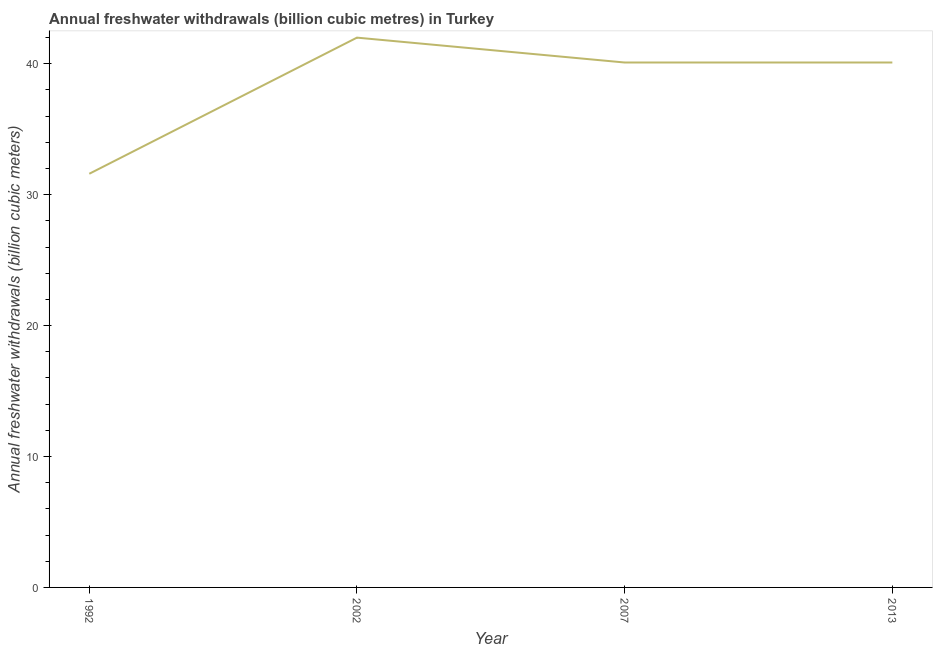What is the annual freshwater withdrawals in 2007?
Your answer should be compact. 40.1. Across all years, what is the minimum annual freshwater withdrawals?
Provide a succinct answer. 31.6. In which year was the annual freshwater withdrawals maximum?
Provide a short and direct response. 2002. What is the sum of the annual freshwater withdrawals?
Make the answer very short. 153.8. What is the difference between the annual freshwater withdrawals in 2002 and 2007?
Ensure brevity in your answer.  1.9. What is the average annual freshwater withdrawals per year?
Keep it short and to the point. 38.45. What is the median annual freshwater withdrawals?
Ensure brevity in your answer.  40.1. In how many years, is the annual freshwater withdrawals greater than 12 billion cubic meters?
Give a very brief answer. 4. Do a majority of the years between 2002 and 1992 (inclusive) have annual freshwater withdrawals greater than 30 billion cubic meters?
Your answer should be compact. No. What is the ratio of the annual freshwater withdrawals in 1992 to that in 2002?
Your answer should be very brief. 0.75. Is the annual freshwater withdrawals in 2007 less than that in 2013?
Give a very brief answer. No. Is the difference between the annual freshwater withdrawals in 2007 and 2013 greater than the difference between any two years?
Your answer should be very brief. No. What is the difference between the highest and the second highest annual freshwater withdrawals?
Your response must be concise. 1.9. What is the difference between the highest and the lowest annual freshwater withdrawals?
Make the answer very short. 10.4. In how many years, is the annual freshwater withdrawals greater than the average annual freshwater withdrawals taken over all years?
Ensure brevity in your answer.  3. Are the values on the major ticks of Y-axis written in scientific E-notation?
Your answer should be very brief. No. Does the graph contain any zero values?
Provide a short and direct response. No. Does the graph contain grids?
Keep it short and to the point. No. What is the title of the graph?
Keep it short and to the point. Annual freshwater withdrawals (billion cubic metres) in Turkey. What is the label or title of the Y-axis?
Give a very brief answer. Annual freshwater withdrawals (billion cubic meters). What is the Annual freshwater withdrawals (billion cubic meters) of 1992?
Provide a succinct answer. 31.6. What is the Annual freshwater withdrawals (billion cubic meters) of 2007?
Your answer should be very brief. 40.1. What is the Annual freshwater withdrawals (billion cubic meters) in 2013?
Provide a succinct answer. 40.1. What is the difference between the Annual freshwater withdrawals (billion cubic meters) in 1992 and 2002?
Make the answer very short. -10.4. What is the difference between the Annual freshwater withdrawals (billion cubic meters) in 1992 and 2007?
Your answer should be very brief. -8.5. What is the difference between the Annual freshwater withdrawals (billion cubic meters) in 1992 and 2013?
Your response must be concise. -8.5. What is the difference between the Annual freshwater withdrawals (billion cubic meters) in 2002 and 2013?
Offer a very short reply. 1.9. What is the ratio of the Annual freshwater withdrawals (billion cubic meters) in 1992 to that in 2002?
Offer a terse response. 0.75. What is the ratio of the Annual freshwater withdrawals (billion cubic meters) in 1992 to that in 2007?
Your answer should be very brief. 0.79. What is the ratio of the Annual freshwater withdrawals (billion cubic meters) in 1992 to that in 2013?
Keep it short and to the point. 0.79. What is the ratio of the Annual freshwater withdrawals (billion cubic meters) in 2002 to that in 2007?
Your response must be concise. 1.05. What is the ratio of the Annual freshwater withdrawals (billion cubic meters) in 2002 to that in 2013?
Provide a short and direct response. 1.05. 